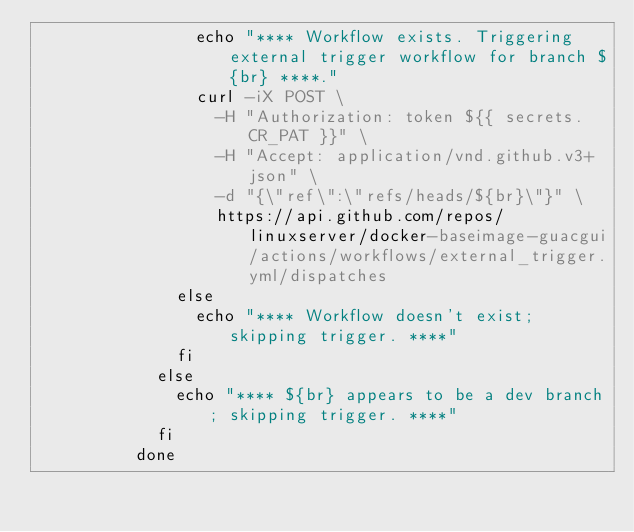<code> <loc_0><loc_0><loc_500><loc_500><_YAML_>                echo "**** Workflow exists. Triggering external trigger workflow for branch ${br} ****."
                curl -iX POST \
                  -H "Authorization: token ${{ secrets.CR_PAT }}" \
                  -H "Accept: application/vnd.github.v3+json" \
                  -d "{\"ref\":\"refs/heads/${br}\"}" \
                  https://api.github.com/repos/linuxserver/docker-baseimage-guacgui/actions/workflows/external_trigger.yml/dispatches
              else
                echo "**** Workflow doesn't exist; skipping trigger. ****"
              fi
            else
              echo "**** ${br} appears to be a dev branch; skipping trigger. ****"
            fi
          done
</code> 